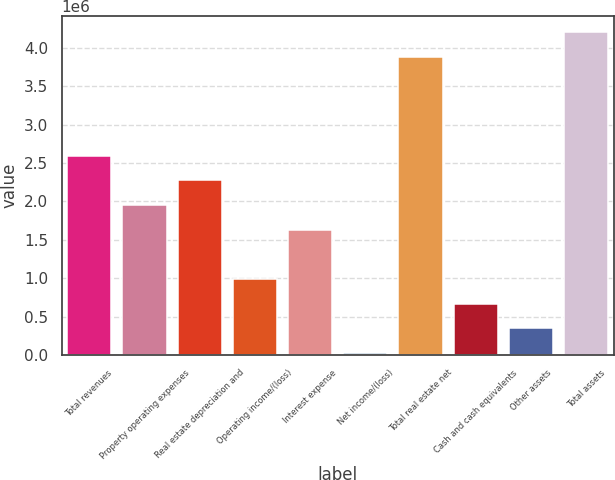Convert chart to OTSL. <chart><loc_0><loc_0><loc_500><loc_500><bar_chart><fcel>Total revenues<fcel>Property operating expenses<fcel>Real estate depreciation and<fcel>Operating income/(loss)<fcel>Interest expense<fcel>Net income/(loss)<fcel>Total real estate net<fcel>Cash and cash equivalents<fcel>Other assets<fcel>Total assets<nl><fcel>2.5953e+06<fcel>1.9534e+06<fcel>2.27435e+06<fcel>990545<fcel>1.63245e+06<fcel>27690<fcel>3.87911e+06<fcel>669594<fcel>348642<fcel>4.20006e+06<nl></chart> 